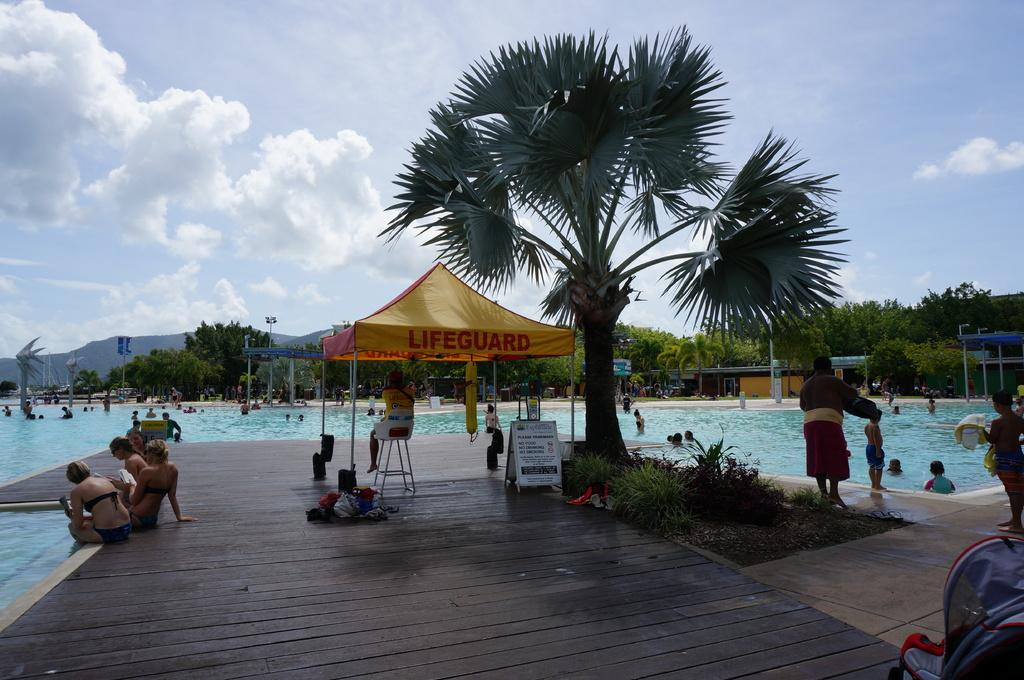What are the people in the image doing? The people in the image are in the swimming pool. Are there any people not in the swimming pool? Yes, there are people near the swimming pool. What can be seen in the background of the image? Trees are visible in the image. What type of temporary shelter is present in the image? There are tents in the image. What type of glue is being used to hold the jeans together in the image? There is no glue or jeans present in the image. How do the people in the image say good-bye to each other? The image does not show any interactions between people that would involve saying good-bye. 